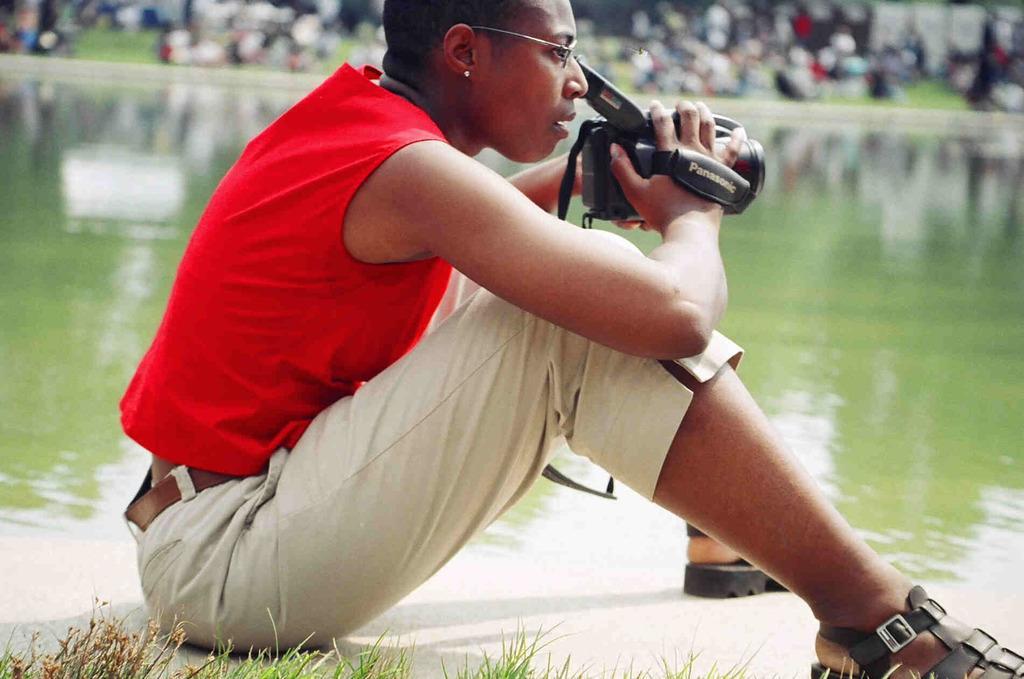Could you give a brief overview of what you see in this image? In the image we can see there is a person sitting on the ground and holding video camera in her hand. Behind there is water and background of the image is blurred. 